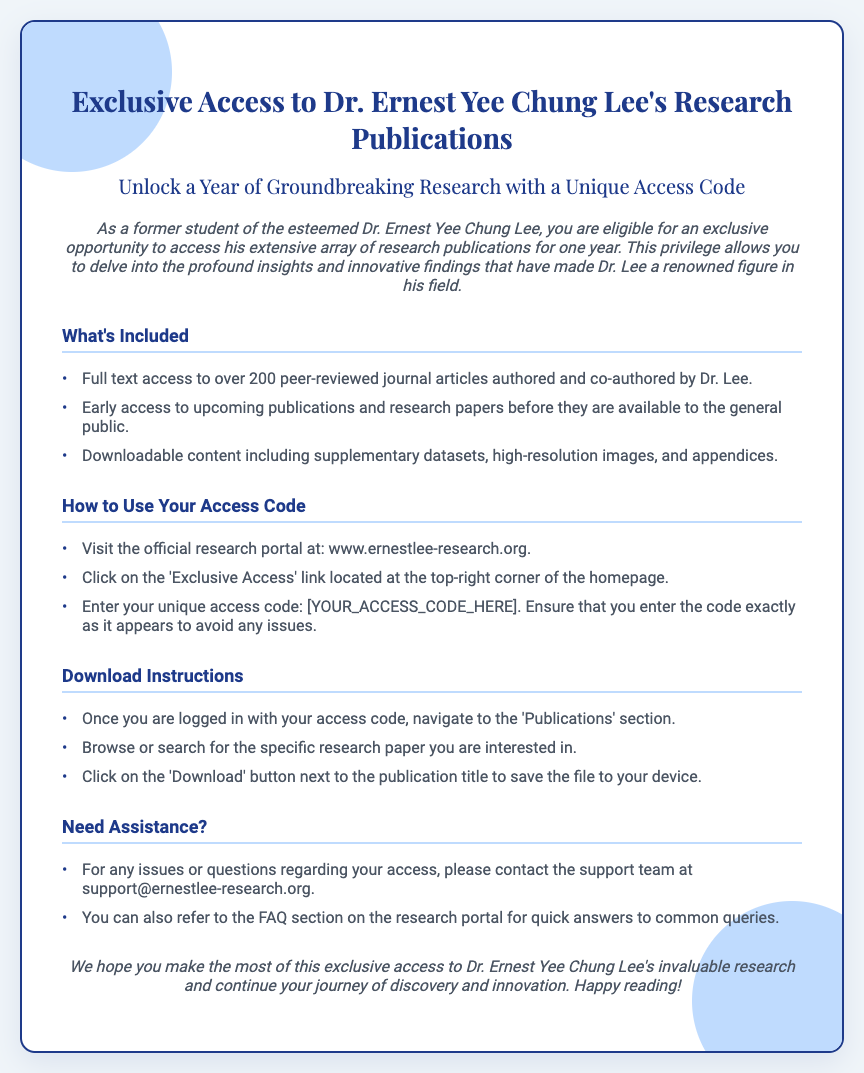What is the duration of access? The document specifies that the access is available for one year.
Answer: One year How many journal articles can you access? The document states there is full text access to over 200 peer-reviewed journal articles.
Answer: Over 200 What is the website to access the publications? The document provides the official research portal's URL for accessing the publications.
Answer: www.ernestlee-research.org What should you do if you have issues with access? The document lists the support email for assistance with access issues.
Answer: support@ernestlee-research.org What type of content is downloadable? The document indicates that the downloadable content includes supplementary datasets, high-resolution images, and appendices.
Answer: Supplementary datasets, high-resolution images, and appendices What is needed to access the publications? The document mentions that a unique access code is required for access.
Answer: Unique access code Where can you find the 'Exclusive Access' link? The document specifies the location of the 'Exclusive Access' link on the research portal's homepage.
Answer: Top-right corner of the homepage What should you click to download a publication? The document states that you should click on the 'Download' button next to the publication title.
Answer: Download button 